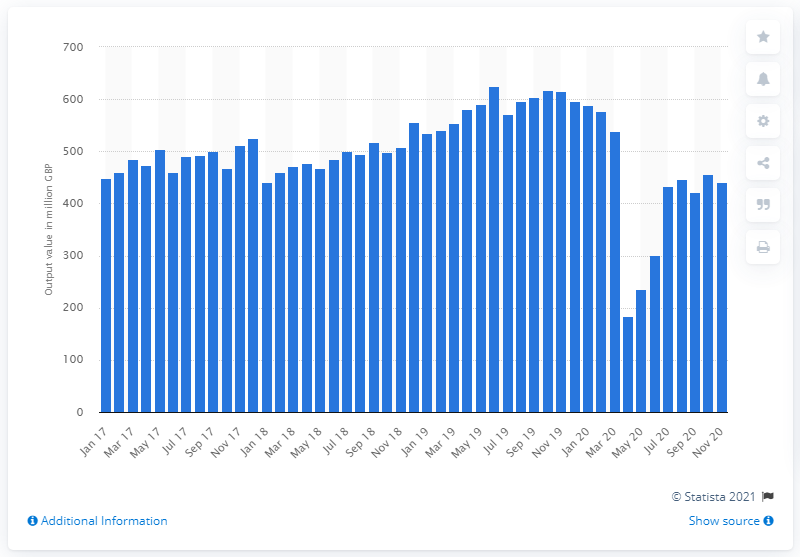List a handful of essential elements in this visual. In April 2020, the value of construction output for new public housing was 184 million. 